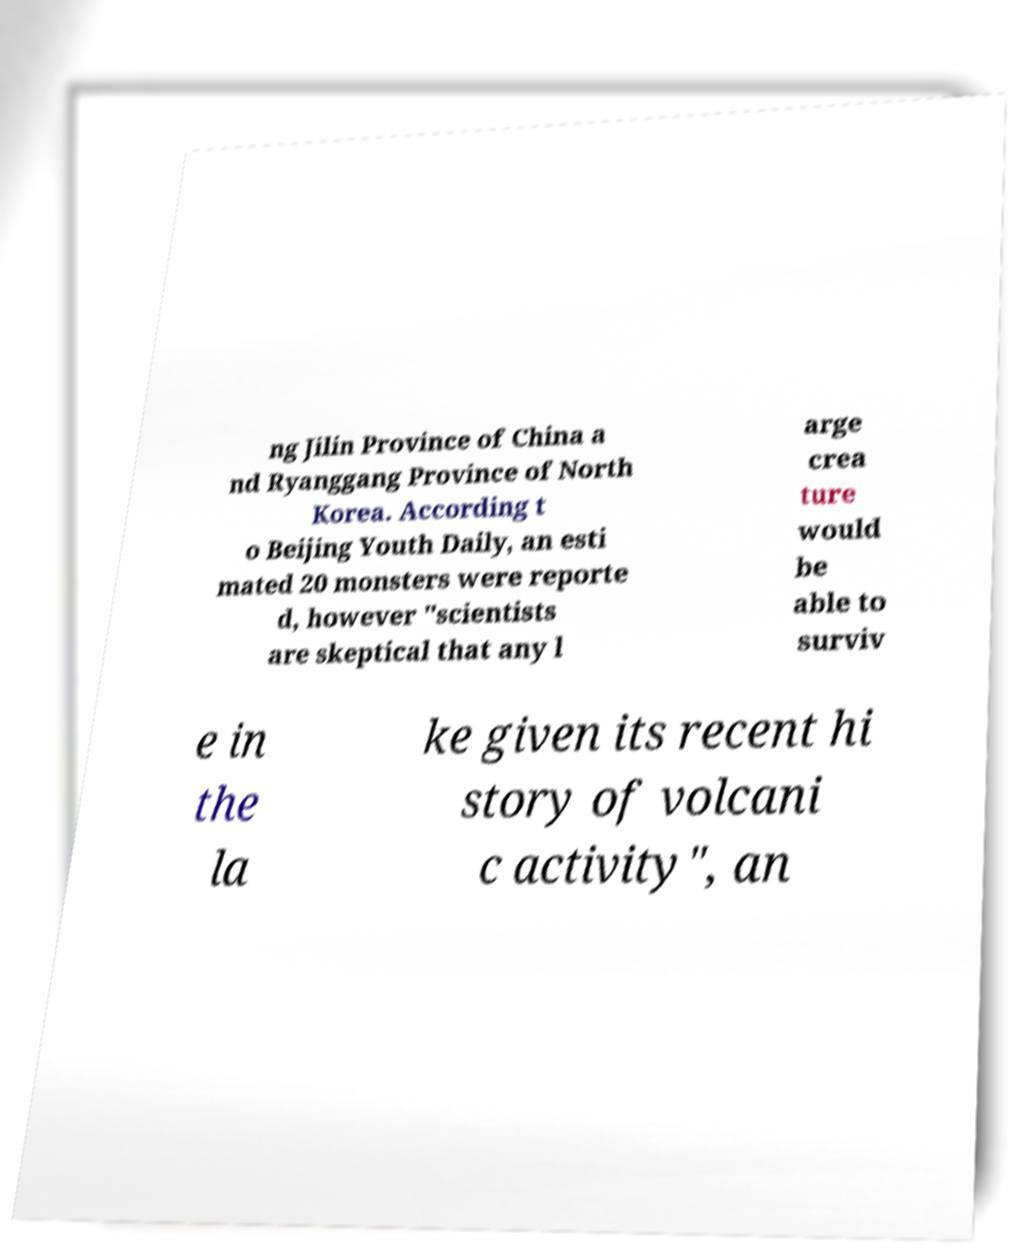Could you extract and type out the text from this image? ng Jilin Province of China a nd Ryanggang Province of North Korea. According t o Beijing Youth Daily, an esti mated 20 monsters were reporte d, however "scientists are skeptical that any l arge crea ture would be able to surviv e in the la ke given its recent hi story of volcani c activity", an 